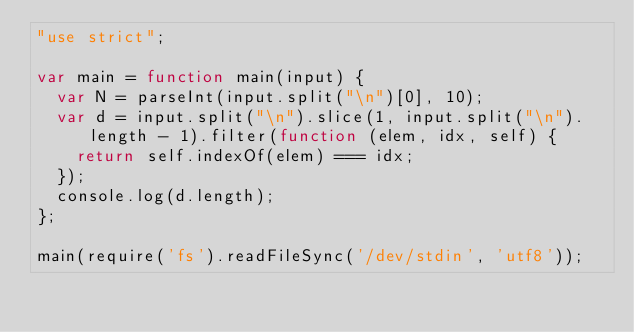<code> <loc_0><loc_0><loc_500><loc_500><_JavaScript_>"use strict";

var main = function main(input) {
  var N = parseInt(input.split("\n")[0], 10);
  var d = input.split("\n").slice(1, input.split("\n").length - 1).filter(function (elem, idx, self) {
    return self.indexOf(elem) === idx;
  });
  console.log(d.length);
};

main(require('fs').readFileSync('/dev/stdin', 'utf8'));</code> 